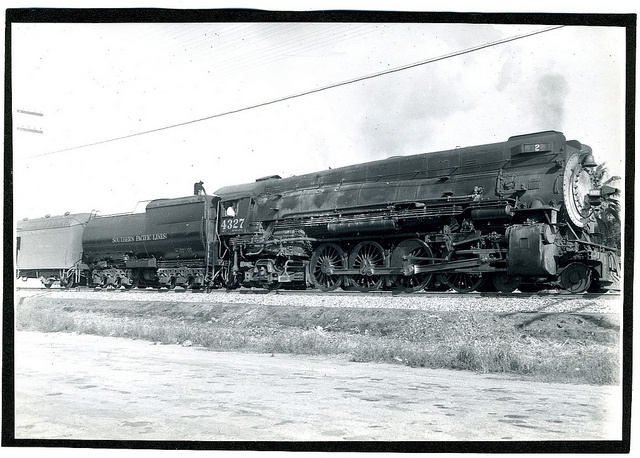Describe the objects in this image and their specific colors. I can see train in white, black, gray, darkgray, and lightgray tones and people in white, gray, darkgray, and black tones in this image. 